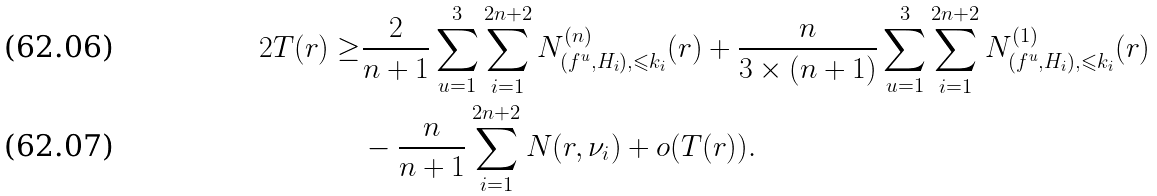<formula> <loc_0><loc_0><loc_500><loc_500>2 T ( r ) \geq & \frac { 2 } { n + 1 } \sum _ { u = 1 } ^ { 3 } \sum _ { i = 1 } ^ { 2 n + 2 } N ^ { ( n ) } _ { ( f ^ { u } , H _ { i } ) , \leqslant k _ { i } } ( r ) + \frac { n } { 3 \times ( n + 1 ) } \sum _ { u = 1 } ^ { 3 } \sum _ { i = 1 } ^ { 2 n + 2 } N ^ { ( 1 ) } _ { ( f ^ { u } , H _ { i } ) , \leqslant k _ { i } } ( r ) \\ & - \frac { n } { n + 1 } \sum _ { i = 1 } ^ { 2 n + 2 } N ( r , \nu _ { i } ) + o ( T ( r ) ) .</formula> 